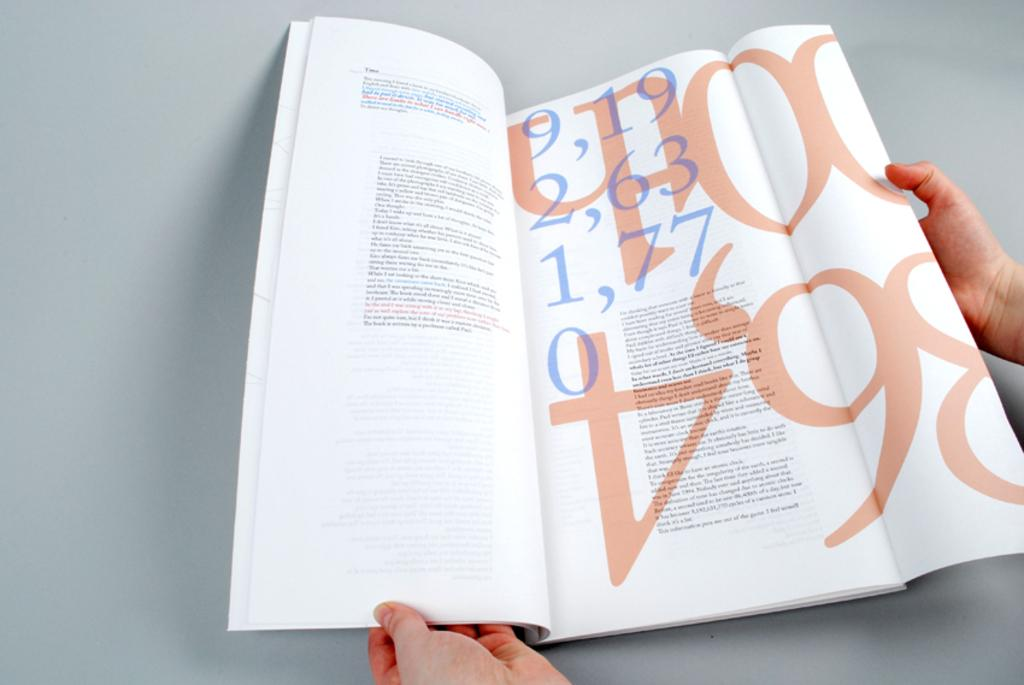What is being held in the hands in the image? There are hands holding a book in the image. What can be found inside the book? The book contains text. On what surface is the book placed? The book is placed on a surface. What type of balloon can be seen floating near the seashore in the image? There is no seashore or balloon present in the image. 